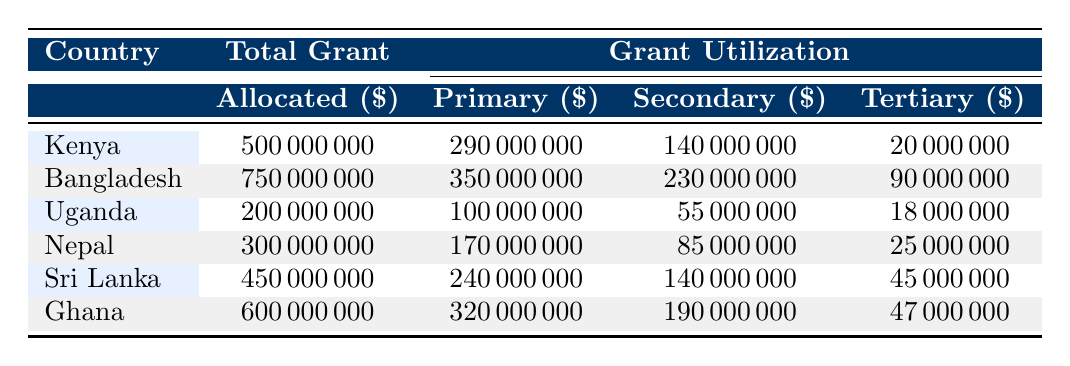What was the total grant allocated to Bangladesh in 2022? The table shows that Bangladesh's total grant allocated for the financial year 2022 is listed directly in the row for Bangladesh.
Answer: 750000000 Which country had the highest grant utilized for primary education? By comparing the figures in the primary education utilization column across all countries, it is clear that Bangladesh, with a utilization of 350000000, has the highest amount utilized for primary education.
Answer: Bangladesh What is the difference between the total grants allocated to Kenya and Uganda? The total grant allocated to Kenya is 500000000, and to Uganda it's 200000000. The difference can be calculated by subtracting Uganda's total from Kenya's: 500000000 - 200000000 = 300000000.
Answer: 300000000 Did any country utilize less than 80% of its allocated grant for tertiary education? Looking at the tertiary education utilization for each country, only Ghana utilized 47000000 out of an allocated 50000000, which is 94%, while Uganda utilized 18000000 out of 20000000, which is 90%. The only country that utilized less than 80% is Sri Lanka, with 45000000 out of 50000000, which is 90%. Thus, the statement is false.
Answer: No What is the average grant allocated to the countries in this table? To find the average grant allocated, first, add all the total grants: 500000000 (Kenya) + 750000000 (Bangladesh) + 200000000 (Uganda) + 300000000 (Nepal) + 450000000 (Sri Lanka) + 600000000 (Ghana) = 2800000000. Then divide by the number of countries (6): 2800000000 / 6 = 466666666.67.
Answer: 466666666.67 